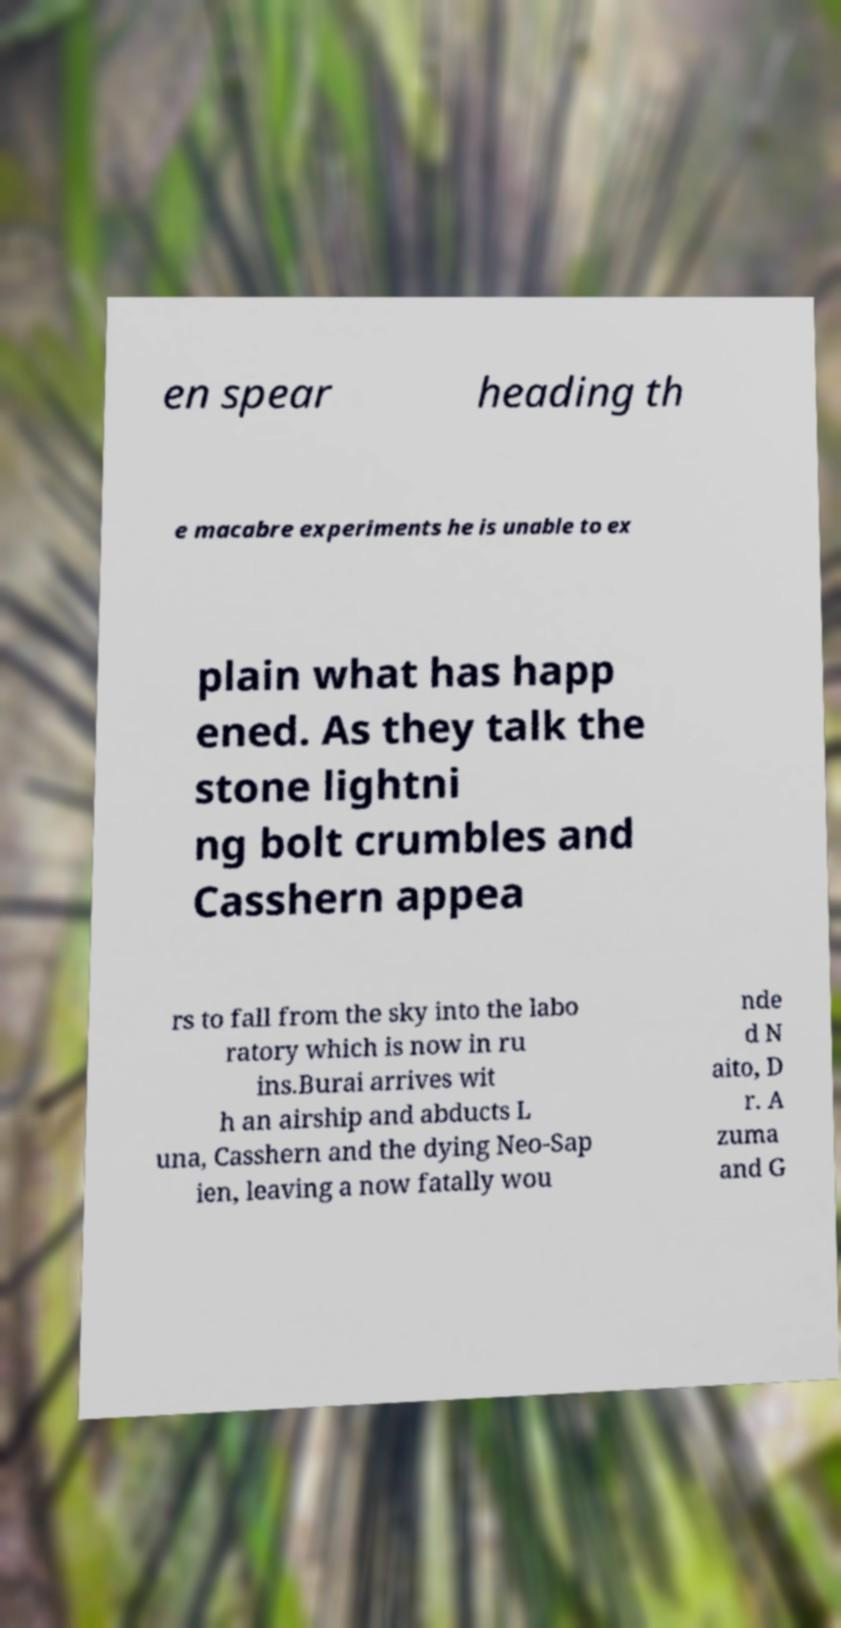For documentation purposes, I need the text within this image transcribed. Could you provide that? en spear heading th e macabre experiments he is unable to ex plain what has happ ened. As they talk the stone lightni ng bolt crumbles and Casshern appea rs to fall from the sky into the labo ratory which is now in ru ins.Burai arrives wit h an airship and abducts L una, Casshern and the dying Neo-Sap ien, leaving a now fatally wou nde d N aito, D r. A zuma and G 